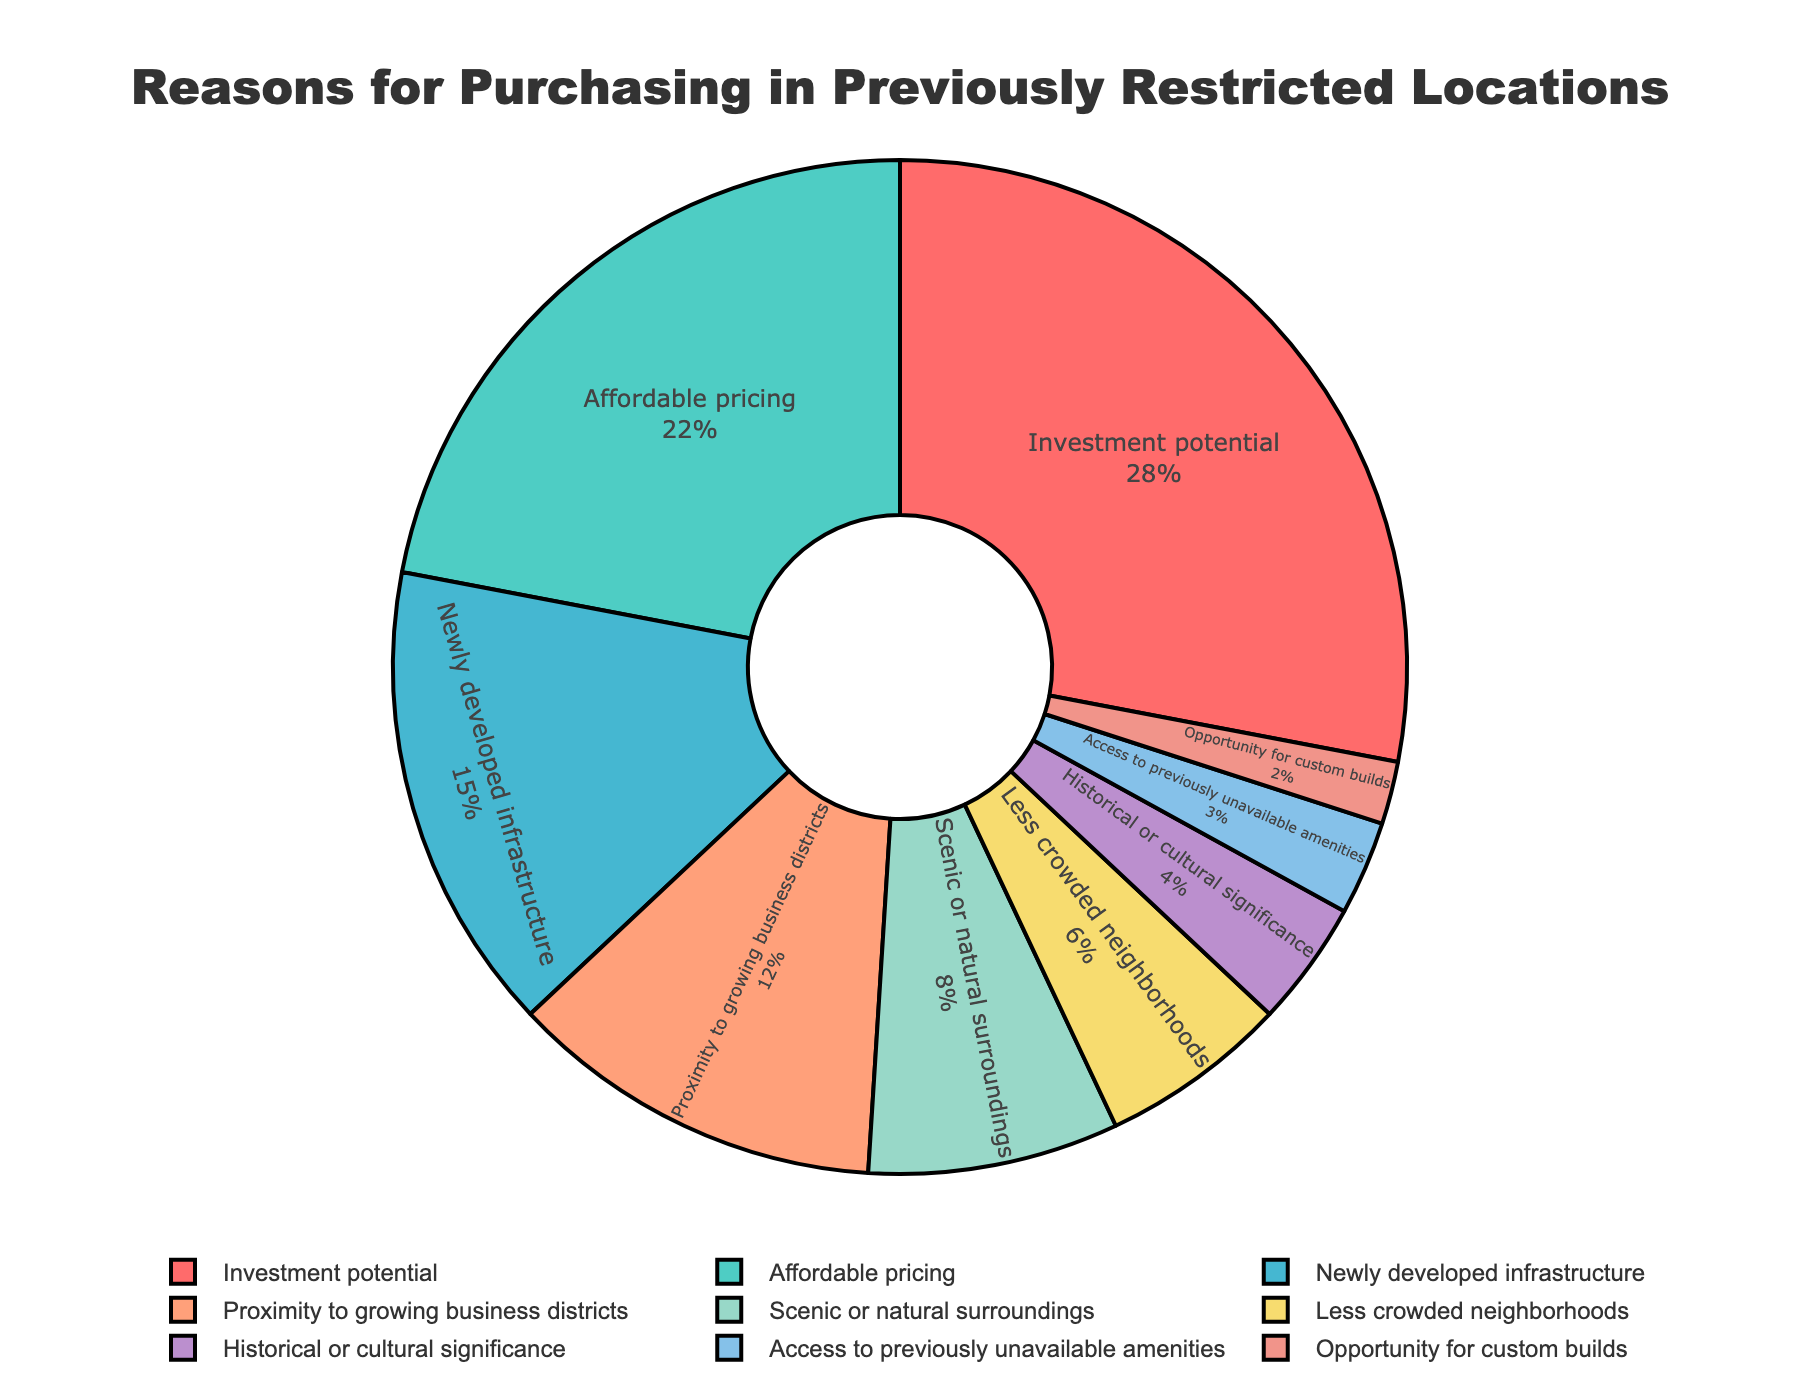which reason has the highest percentage? The figure shows that the "Investment potential" segment is the largest.
Answer: Investment potential which reason has the lowest percentage? The figure shows that the "Opportunity for custom builds" segment is the smallest.
Answer: Opportunity for custom builds how do the percentages of "affordable pricing" and "newly developed infrastructure" compare? The "Affordable pricing" segment is 22%, and the "Newly developed infrastructure" segment is 15%. 22% is greater than 15%.
Answer: Affordable pricing is greater than newly developed infrastructure what is the combined percentage for "scenic or natural surroundings" and "less crowded neighborhoods"? The "Scenic or natural surroundings" segment is 8%, and the "Less crowded neighborhoods" segment is 6%. Summing these gives 8% + 6% = 14%.
Answer: 14% is the percentage for "historical or cultural significance" greater than that for "access to previously unavailable amenities"? The "Historical or cultural significance" segment is 4%, and the "Access to previously unavailable amenities" segment is 3%. 4% is greater than 3%.
Answer: Yes what is the difference in percentage between "proximity to growing business districts" and "affordable pricing"? The "Proximity to growing business districts" segment is 12%, and the "Affordable pricing" segment is 22%. The difference is 22% - 12% = 10%.
Answer: 10% which reason has the highest percentage of purchasing due to natural surroundings or less crowded neighborhoods? The "Scenic or natural surroundings" segment is 8%, while the "Less crowded neighborhoods" segment is 6%. 8% is greater than 6%.
Answer: Scenic or natural surroundings what percentage of buyers bought due to investment potential, newly developed infrastructure, and proximity to growing business districts combined? The "Investment potential" segment is 28%, the "Newly developed infrastructure" segment is 15%, and the "Proximity to growing business districts" segment is 12%. Summing these gives 28% + 15% + 12% = 55%.
Answer: 55% what is the percentage difference between the highest and lowest reasons for purchasing? The highest percentage is "Investment potential" at 28%, and the lowest percentage is "Opportunity for custom builds" at 2%. The difference is 28% - 2% = 26%.
Answer: 26% how many segments are there for reasons with percentages less than 10%? The segments with percentages less than 10% are "Scenic or natural surroundings" (8%), "Less crowded neighborhoods" (6%), "Historical or cultural significance" (4%), "Access to previously unavailable amenities" (3%), and "Opportunity for custom builds" (2%). There are 5 such segments.
Answer: 5 